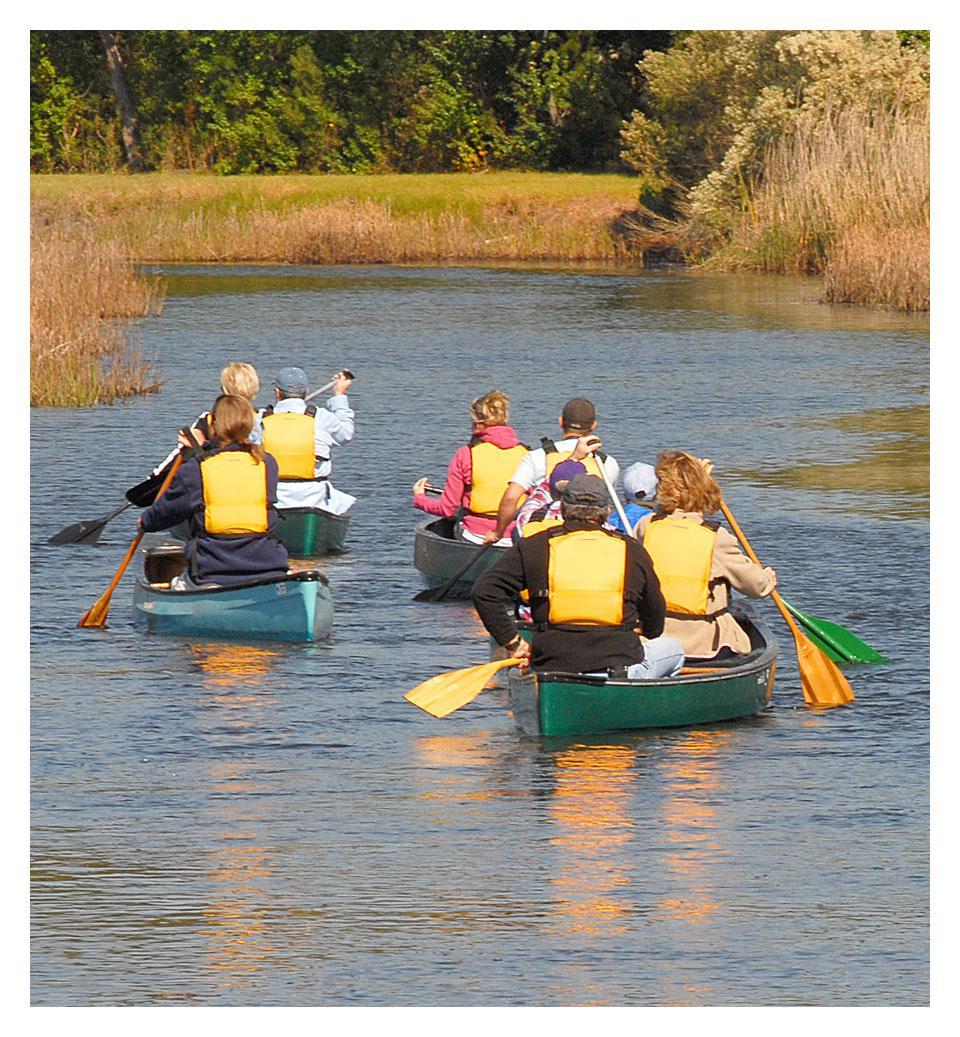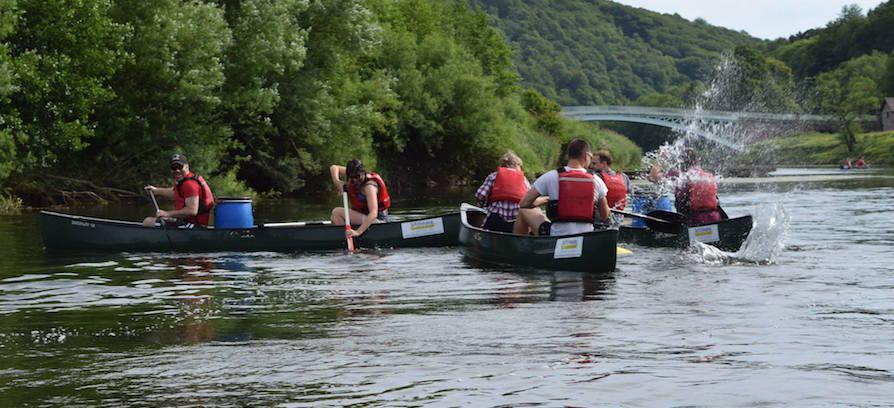The first image is the image on the left, the second image is the image on the right. Assess this claim about the two images: "A group of people are in canoes with their hands in the air.". Correct or not? Answer yes or no. No. 